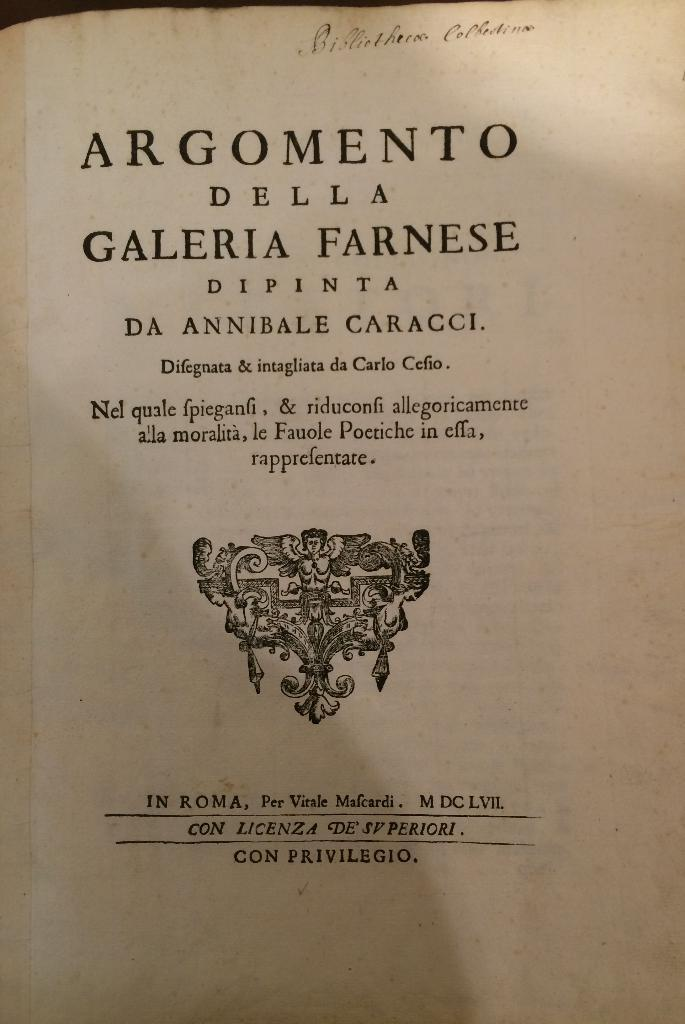<image>
Provide a brief description of the given image. a page that is titled 'argomento della galeria farnese' 